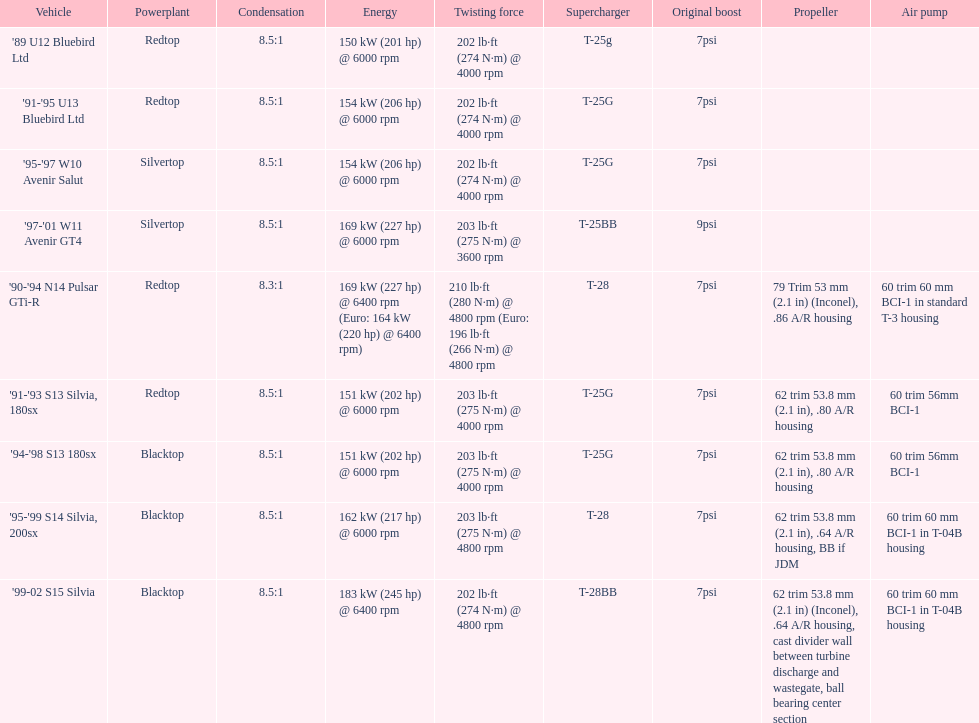Can you parse all the data within this table? {'header': ['Vehicle', 'Powerplant', 'Condensation', 'Energy', 'Twisting force', 'Supercharger', 'Original boost', 'Propeller', 'Air pump'], 'rows': [["'89 U12 Bluebird Ltd", 'Redtop', '8.5:1', '150\xa0kW (201\xa0hp) @ 6000 rpm', '202\xa0lb·ft (274\xa0N·m) @ 4000 rpm', 'T-25g', '7psi', '', ''], ["'91-'95 U13 Bluebird Ltd", 'Redtop', '8.5:1', '154\xa0kW (206\xa0hp) @ 6000 rpm', '202\xa0lb·ft (274\xa0N·m) @ 4000 rpm', 'T-25G', '7psi', '', ''], ["'95-'97 W10 Avenir Salut", 'Silvertop', '8.5:1', '154\xa0kW (206\xa0hp) @ 6000 rpm', '202\xa0lb·ft (274\xa0N·m) @ 4000 rpm', 'T-25G', '7psi', '', ''], ["'97-'01 W11 Avenir GT4", 'Silvertop', '8.5:1', '169\xa0kW (227\xa0hp) @ 6000 rpm', '203\xa0lb·ft (275\xa0N·m) @ 3600 rpm', 'T-25BB', '9psi', '', ''], ["'90-'94 N14 Pulsar GTi-R", 'Redtop', '8.3:1', '169\xa0kW (227\xa0hp) @ 6400 rpm (Euro: 164\xa0kW (220\xa0hp) @ 6400 rpm)', '210\xa0lb·ft (280\xa0N·m) @ 4800 rpm (Euro: 196\xa0lb·ft (266\xa0N·m) @ 4800 rpm', 'T-28', '7psi', '79 Trim 53\xa0mm (2.1\xa0in) (Inconel), .86 A/R housing', '60 trim 60\xa0mm BCI-1 in standard T-3 housing'], ["'91-'93 S13 Silvia, 180sx", 'Redtop', '8.5:1', '151\xa0kW (202\xa0hp) @ 6000 rpm', '203\xa0lb·ft (275\xa0N·m) @ 4000 rpm', 'T-25G', '7psi', '62 trim 53.8\xa0mm (2.1\xa0in), .80 A/R housing', '60 trim 56mm BCI-1'], ["'94-'98 S13 180sx", 'Blacktop', '8.5:1', '151\xa0kW (202\xa0hp) @ 6000 rpm', '203\xa0lb·ft (275\xa0N·m) @ 4000 rpm', 'T-25G', '7psi', '62 trim 53.8\xa0mm (2.1\xa0in), .80 A/R housing', '60 trim 56mm BCI-1'], ["'95-'99 S14 Silvia, 200sx", 'Blacktop', '8.5:1', '162\xa0kW (217\xa0hp) @ 6000 rpm', '203\xa0lb·ft (275\xa0N·m) @ 4800 rpm', 'T-28', '7psi', '62 trim 53.8\xa0mm (2.1\xa0in), .64 A/R housing, BB if JDM', '60 trim 60\xa0mm BCI-1 in T-04B housing'], ["'99-02 S15 Silvia", 'Blacktop', '8.5:1', '183\xa0kW (245\xa0hp) @ 6400 rpm', '202\xa0lb·ft (274\xa0N·m) @ 4800 rpm', 'T-28BB', '7psi', '62 trim 53.8\xa0mm (2.1\xa0in) (Inconel), .64 A/R housing, cast divider wall between turbine discharge and wastegate, ball bearing center section', '60 trim 60\xa0mm BCI-1 in T-04B housing']]} In which engine can the smallest compression rate be found? '90-'94 N14 Pulsar GTi-R. 